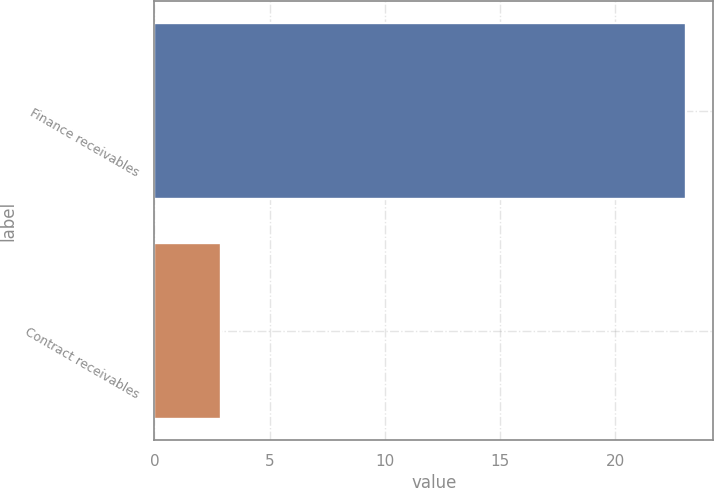<chart> <loc_0><loc_0><loc_500><loc_500><bar_chart><fcel>Finance receivables<fcel>Contract receivables<nl><fcel>23.1<fcel>2.9<nl></chart> 